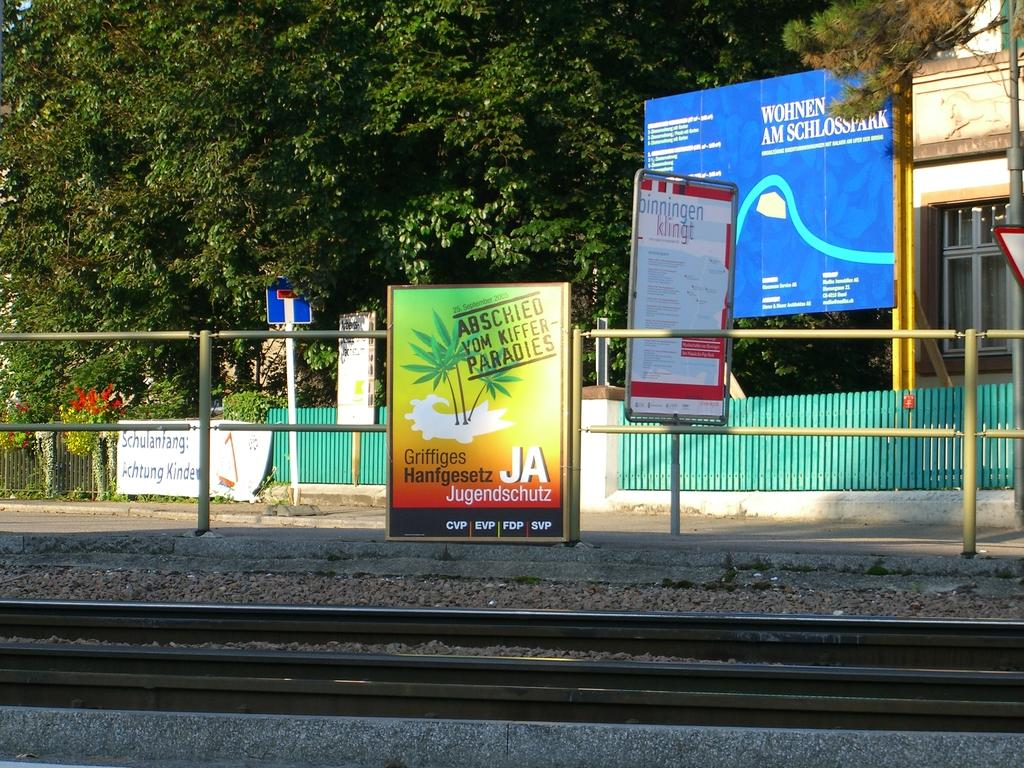What can be seen on the boards in the image? There are boards with text in the image. What type of transportation infrastructure is present in the image? There is a railway track in the image. What material is used for the railing in the image? There is metal railing in the image. What structure is located on the right side of the image? There is a building on the right side of the image. What type of barrier is present in the image? There is a wooden fence in the image. What can be seen in the background of the image? There are trees in the background of the image. How many kittens are playing with the wooden fence in the image? There are no kittens present in the image; it features boards with text, a railway track, metal railing, a building, a wooden fence, and trees in the background. What type of channel is used for communication in the image? There is no communication channel present in the image; it focuses on physical objects and structures. 